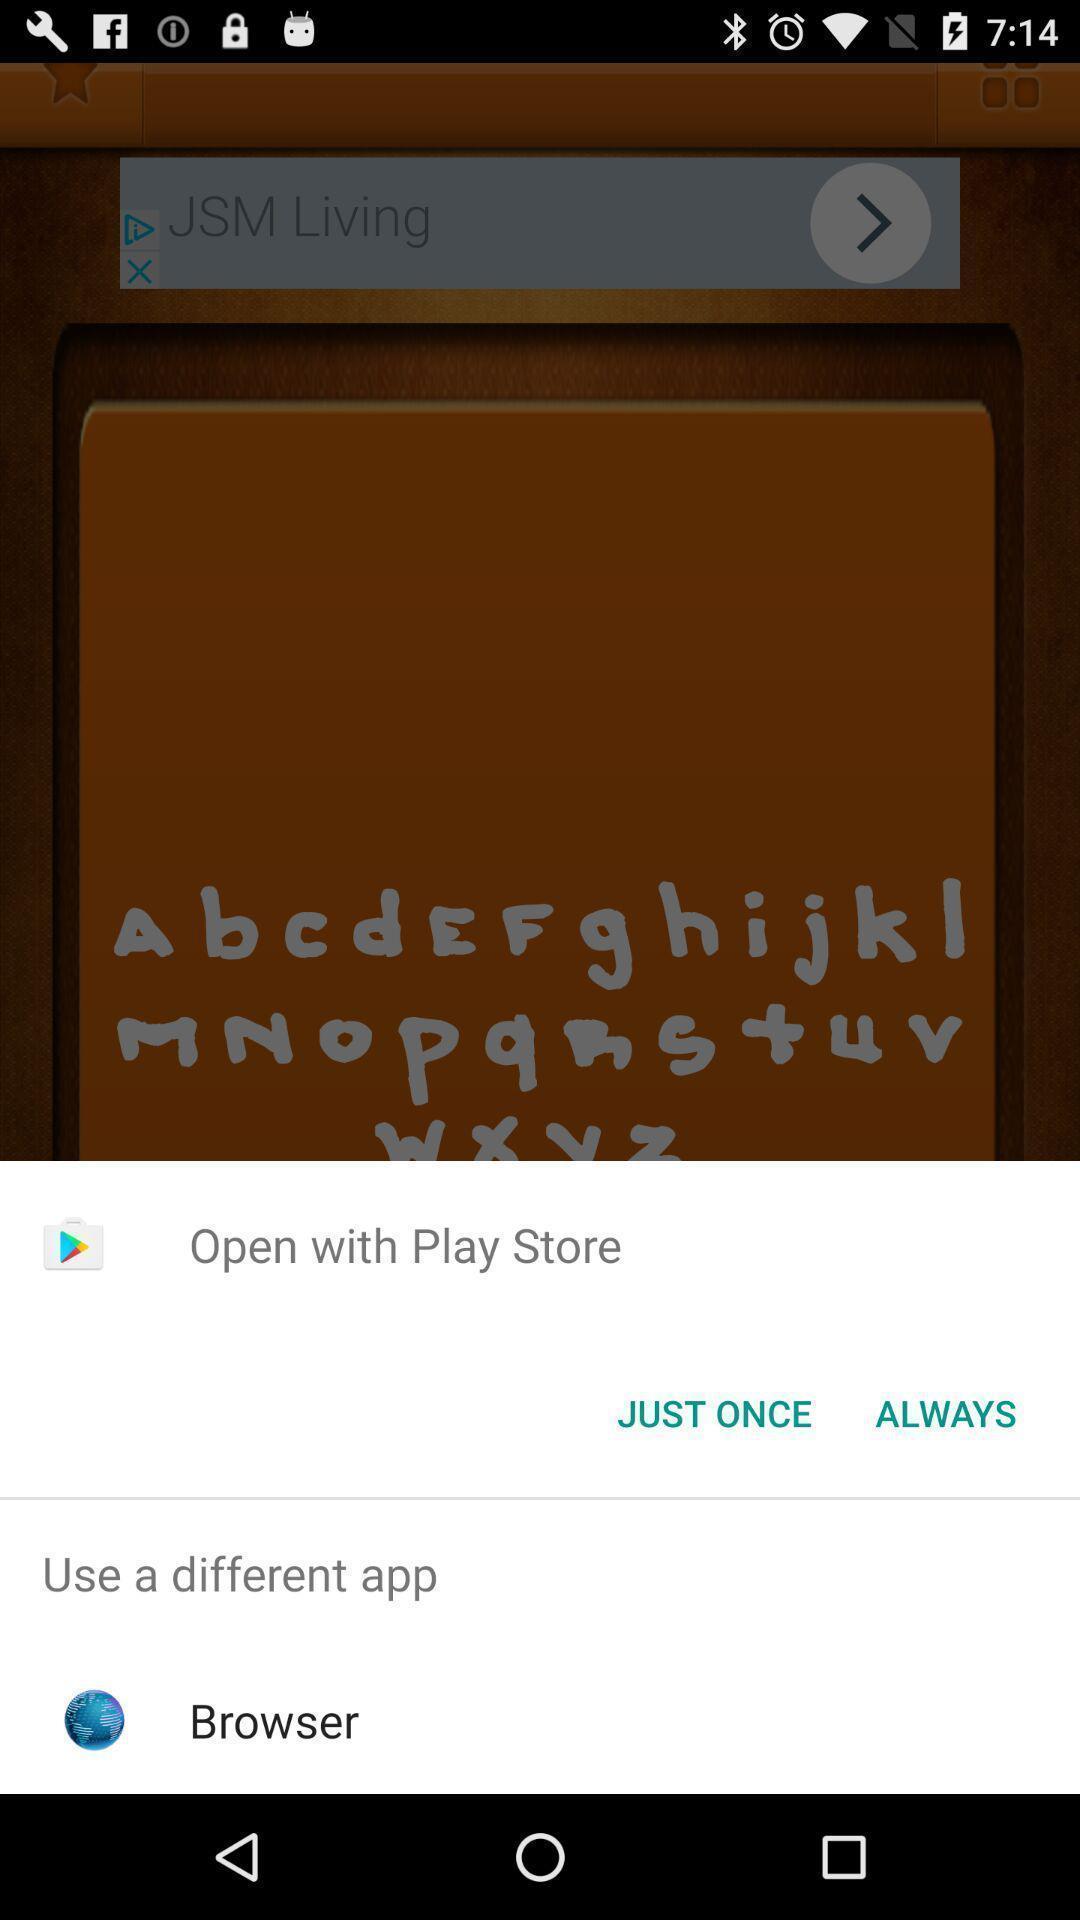What details can you identify in this image? Push up message for opening the app via social networks. 